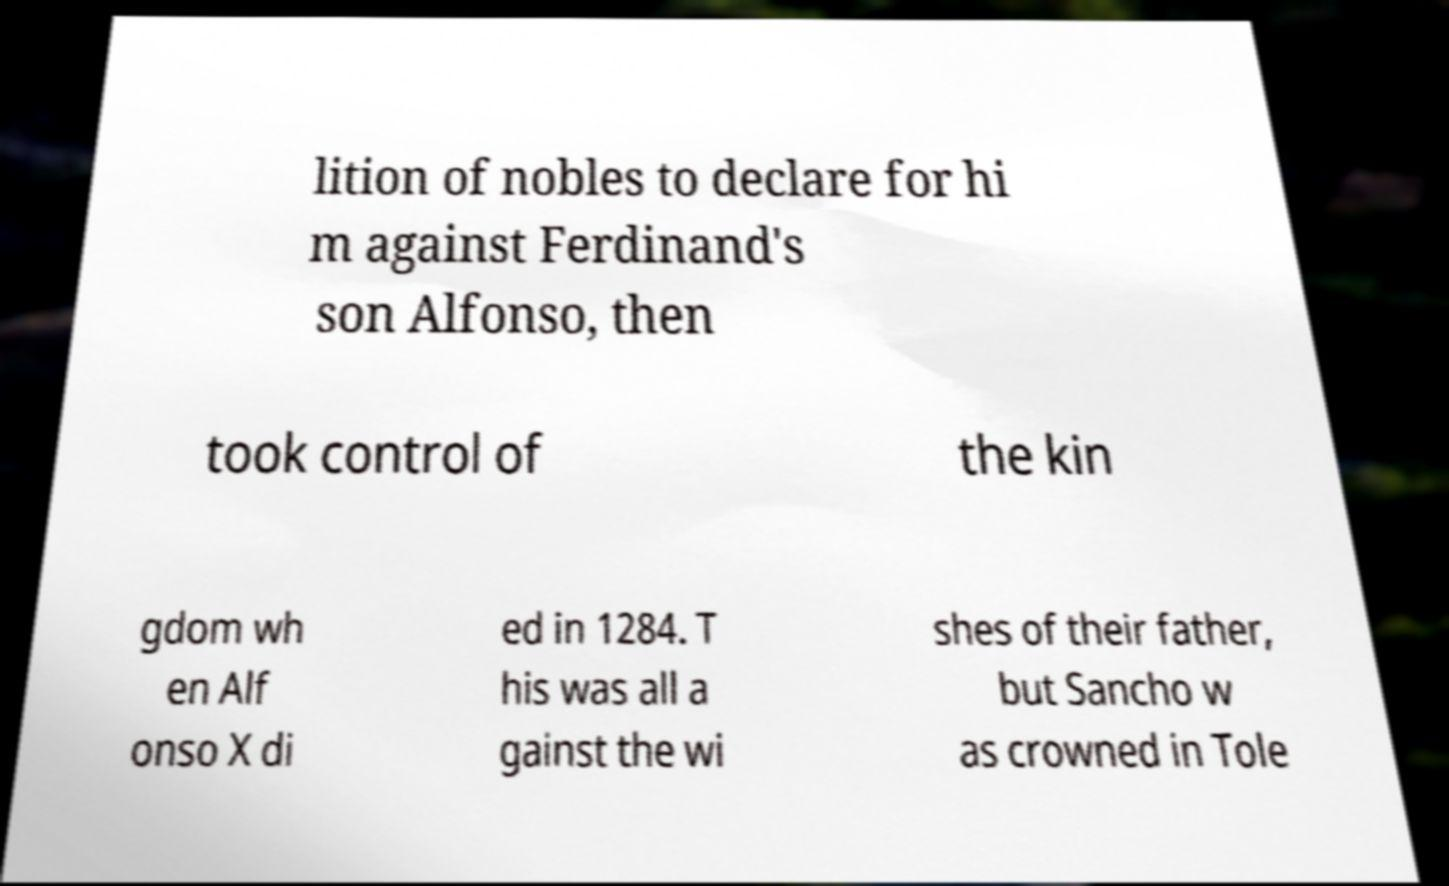Can you read and provide the text displayed in the image?This photo seems to have some interesting text. Can you extract and type it out for me? lition of nobles to declare for hi m against Ferdinand's son Alfonso, then took control of the kin gdom wh en Alf onso X di ed in 1284. T his was all a gainst the wi shes of their father, but Sancho w as crowned in Tole 